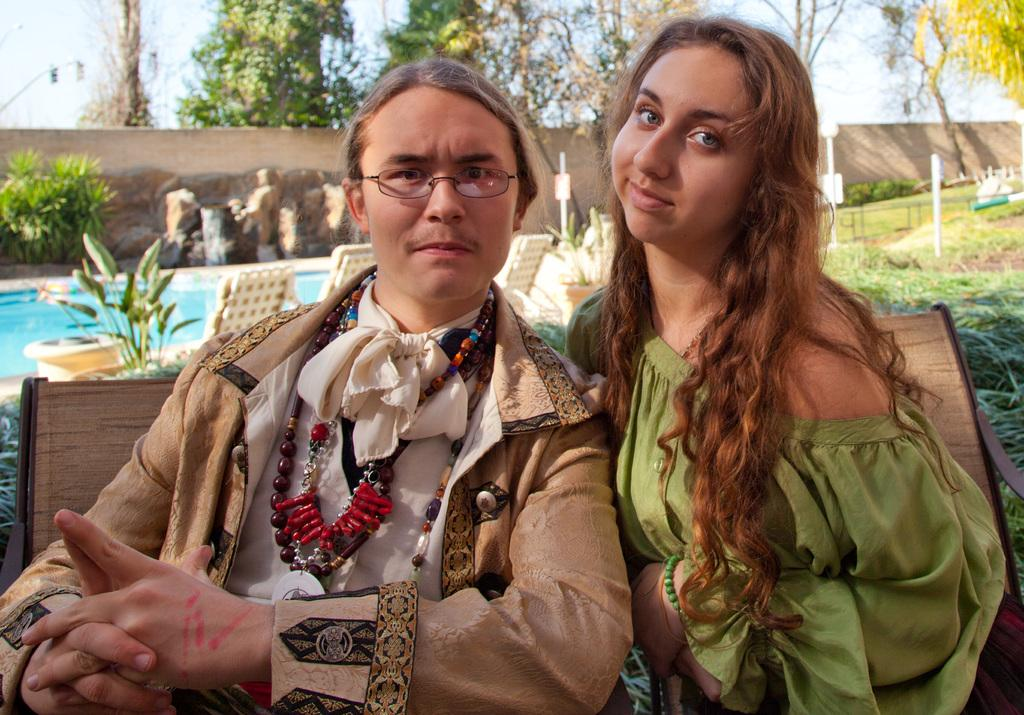How many people are sitting on the bench in the image? There are 2 people sitting on a bench in the image. What type of surface is visible beneath the people? There is grass in the image. What other objects are present in the image? There are plants, chairs, water, a wall, and trees behind the wall visible in the image. What type of action is the ghost performing in the image? There is no ghost present in the image, so it is not possible to answer that question. 